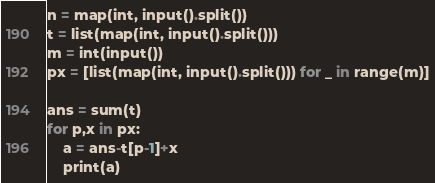Convert code to text. <code><loc_0><loc_0><loc_500><loc_500><_Python_>n = map(int, input().split())
t = list(map(int, input().split()))
m = int(input())
px = [list(map(int, input().split())) for _ in range(m)]

ans = sum(t)
for p,x in px:
    a = ans-t[p-1]+x
    print(a)</code> 